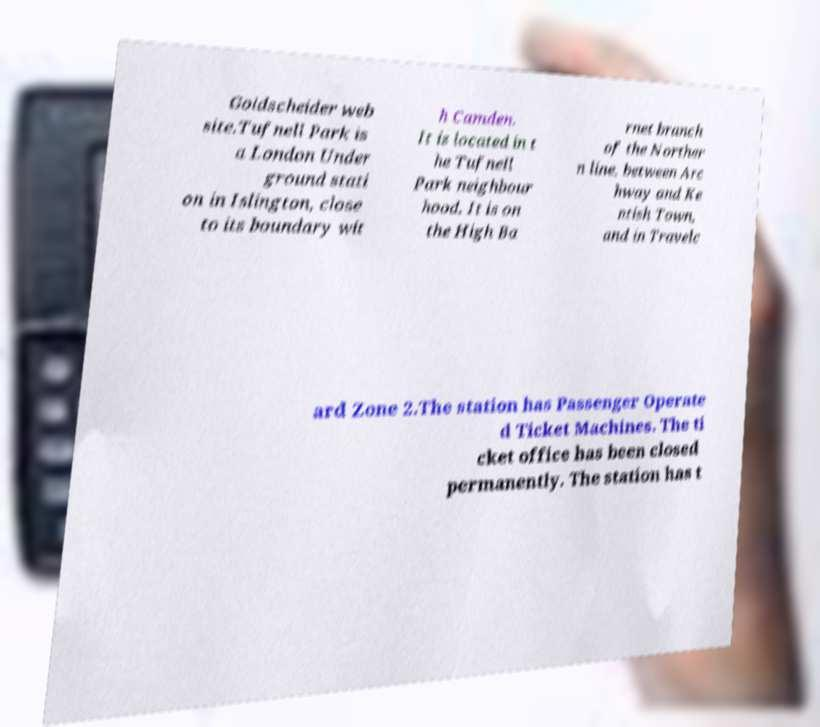Could you assist in decoding the text presented in this image and type it out clearly? Goldscheider web site.Tufnell Park is a London Under ground stati on in Islington, close to its boundary wit h Camden. It is located in t he Tufnell Park neighbour hood. It is on the High Ba rnet branch of the Norther n line, between Arc hway and Ke ntish Town, and in Travelc ard Zone 2.The station has Passenger Operate d Ticket Machines. The ti cket office has been closed permanently. The station has t 